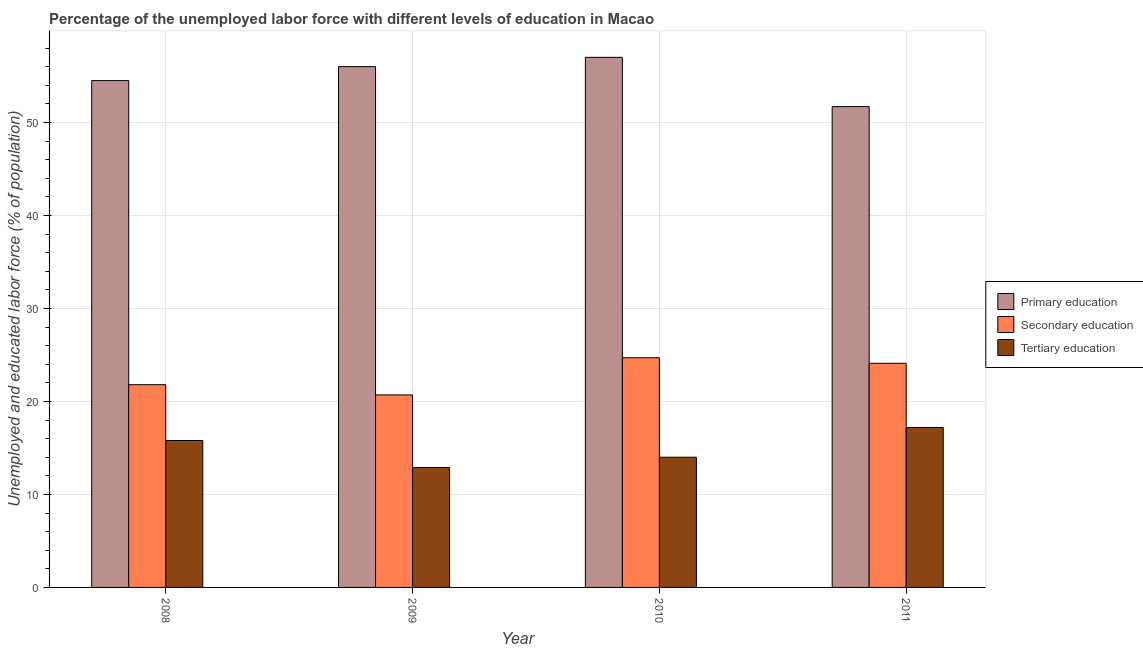How many groups of bars are there?
Make the answer very short. 4. Are the number of bars per tick equal to the number of legend labels?
Keep it short and to the point. Yes. How many bars are there on the 1st tick from the right?
Ensure brevity in your answer.  3. What is the label of the 1st group of bars from the left?
Ensure brevity in your answer.  2008. What is the percentage of labor force who received secondary education in 2008?
Offer a terse response. 21.8. Across all years, what is the minimum percentage of labor force who received secondary education?
Make the answer very short. 20.7. In which year was the percentage of labor force who received secondary education maximum?
Keep it short and to the point. 2010. What is the total percentage of labor force who received tertiary education in the graph?
Give a very brief answer. 59.9. What is the difference between the percentage of labor force who received secondary education in 2008 and that in 2011?
Offer a terse response. -2.3. What is the difference between the percentage of labor force who received primary education in 2011 and the percentage of labor force who received secondary education in 2009?
Your response must be concise. -4.3. What is the average percentage of labor force who received tertiary education per year?
Provide a succinct answer. 14.98. In the year 2010, what is the difference between the percentage of labor force who received secondary education and percentage of labor force who received tertiary education?
Your answer should be very brief. 0. What is the ratio of the percentage of labor force who received tertiary education in 2008 to that in 2011?
Give a very brief answer. 0.92. What is the difference between the highest and the second highest percentage of labor force who received primary education?
Give a very brief answer. 1. What is the difference between the highest and the lowest percentage of labor force who received tertiary education?
Make the answer very short. 4.3. What does the 3rd bar from the left in 2010 represents?
Offer a very short reply. Tertiary education. How many bars are there?
Your answer should be very brief. 12. Are all the bars in the graph horizontal?
Your response must be concise. No. How many years are there in the graph?
Keep it short and to the point. 4. Does the graph contain any zero values?
Your response must be concise. No. How many legend labels are there?
Make the answer very short. 3. How are the legend labels stacked?
Give a very brief answer. Vertical. What is the title of the graph?
Your answer should be compact. Percentage of the unemployed labor force with different levels of education in Macao. Does "Taxes on goods and services" appear as one of the legend labels in the graph?
Offer a very short reply. No. What is the label or title of the X-axis?
Offer a terse response. Year. What is the label or title of the Y-axis?
Your answer should be very brief. Unemployed and educated labor force (% of population). What is the Unemployed and educated labor force (% of population) of Primary education in 2008?
Ensure brevity in your answer.  54.5. What is the Unemployed and educated labor force (% of population) in Secondary education in 2008?
Ensure brevity in your answer.  21.8. What is the Unemployed and educated labor force (% of population) in Tertiary education in 2008?
Your answer should be compact. 15.8. What is the Unemployed and educated labor force (% of population) in Secondary education in 2009?
Your answer should be compact. 20.7. What is the Unemployed and educated labor force (% of population) of Tertiary education in 2009?
Your answer should be compact. 12.9. What is the Unemployed and educated labor force (% of population) of Primary education in 2010?
Your answer should be compact. 57. What is the Unemployed and educated labor force (% of population) in Secondary education in 2010?
Give a very brief answer. 24.7. What is the Unemployed and educated labor force (% of population) of Tertiary education in 2010?
Ensure brevity in your answer.  14. What is the Unemployed and educated labor force (% of population) in Primary education in 2011?
Your response must be concise. 51.7. What is the Unemployed and educated labor force (% of population) in Secondary education in 2011?
Provide a succinct answer. 24.1. What is the Unemployed and educated labor force (% of population) in Tertiary education in 2011?
Give a very brief answer. 17.2. Across all years, what is the maximum Unemployed and educated labor force (% of population) of Secondary education?
Offer a terse response. 24.7. Across all years, what is the maximum Unemployed and educated labor force (% of population) of Tertiary education?
Provide a short and direct response. 17.2. Across all years, what is the minimum Unemployed and educated labor force (% of population) in Primary education?
Provide a succinct answer. 51.7. Across all years, what is the minimum Unemployed and educated labor force (% of population) of Secondary education?
Make the answer very short. 20.7. Across all years, what is the minimum Unemployed and educated labor force (% of population) in Tertiary education?
Provide a short and direct response. 12.9. What is the total Unemployed and educated labor force (% of population) of Primary education in the graph?
Make the answer very short. 219.2. What is the total Unemployed and educated labor force (% of population) in Secondary education in the graph?
Give a very brief answer. 91.3. What is the total Unemployed and educated labor force (% of population) of Tertiary education in the graph?
Your answer should be compact. 59.9. What is the difference between the Unemployed and educated labor force (% of population) of Secondary education in 2008 and that in 2009?
Your answer should be compact. 1.1. What is the difference between the Unemployed and educated labor force (% of population) in Primary education in 2008 and that in 2011?
Provide a succinct answer. 2.8. What is the difference between the Unemployed and educated labor force (% of population) of Tertiary education in 2008 and that in 2011?
Your response must be concise. -1.4. What is the difference between the Unemployed and educated labor force (% of population) of Primary education in 2009 and that in 2010?
Your answer should be very brief. -1. What is the difference between the Unemployed and educated labor force (% of population) in Secondary education in 2009 and that in 2010?
Your answer should be compact. -4. What is the difference between the Unemployed and educated labor force (% of population) in Tertiary education in 2009 and that in 2011?
Keep it short and to the point. -4.3. What is the difference between the Unemployed and educated labor force (% of population) in Primary education in 2010 and that in 2011?
Make the answer very short. 5.3. What is the difference between the Unemployed and educated labor force (% of population) of Primary education in 2008 and the Unemployed and educated labor force (% of population) of Secondary education in 2009?
Make the answer very short. 33.8. What is the difference between the Unemployed and educated labor force (% of population) in Primary education in 2008 and the Unemployed and educated labor force (% of population) in Tertiary education in 2009?
Give a very brief answer. 41.6. What is the difference between the Unemployed and educated labor force (% of population) of Secondary education in 2008 and the Unemployed and educated labor force (% of population) of Tertiary education in 2009?
Offer a very short reply. 8.9. What is the difference between the Unemployed and educated labor force (% of population) in Primary education in 2008 and the Unemployed and educated labor force (% of population) in Secondary education in 2010?
Keep it short and to the point. 29.8. What is the difference between the Unemployed and educated labor force (% of population) in Primary education in 2008 and the Unemployed and educated labor force (% of population) in Tertiary education in 2010?
Your answer should be very brief. 40.5. What is the difference between the Unemployed and educated labor force (% of population) of Primary education in 2008 and the Unemployed and educated labor force (% of population) of Secondary education in 2011?
Keep it short and to the point. 30.4. What is the difference between the Unemployed and educated labor force (% of population) of Primary education in 2008 and the Unemployed and educated labor force (% of population) of Tertiary education in 2011?
Offer a very short reply. 37.3. What is the difference between the Unemployed and educated labor force (% of population) of Secondary education in 2008 and the Unemployed and educated labor force (% of population) of Tertiary education in 2011?
Your response must be concise. 4.6. What is the difference between the Unemployed and educated labor force (% of population) in Primary education in 2009 and the Unemployed and educated labor force (% of population) in Secondary education in 2010?
Provide a short and direct response. 31.3. What is the difference between the Unemployed and educated labor force (% of population) of Primary education in 2009 and the Unemployed and educated labor force (% of population) of Secondary education in 2011?
Keep it short and to the point. 31.9. What is the difference between the Unemployed and educated labor force (% of population) of Primary education in 2009 and the Unemployed and educated labor force (% of population) of Tertiary education in 2011?
Give a very brief answer. 38.8. What is the difference between the Unemployed and educated labor force (% of population) of Secondary education in 2009 and the Unemployed and educated labor force (% of population) of Tertiary education in 2011?
Your answer should be very brief. 3.5. What is the difference between the Unemployed and educated labor force (% of population) of Primary education in 2010 and the Unemployed and educated labor force (% of population) of Secondary education in 2011?
Your answer should be very brief. 32.9. What is the difference between the Unemployed and educated labor force (% of population) of Primary education in 2010 and the Unemployed and educated labor force (% of population) of Tertiary education in 2011?
Offer a very short reply. 39.8. What is the average Unemployed and educated labor force (% of population) in Primary education per year?
Give a very brief answer. 54.8. What is the average Unemployed and educated labor force (% of population) in Secondary education per year?
Offer a very short reply. 22.82. What is the average Unemployed and educated labor force (% of population) of Tertiary education per year?
Ensure brevity in your answer.  14.97. In the year 2008, what is the difference between the Unemployed and educated labor force (% of population) of Primary education and Unemployed and educated labor force (% of population) of Secondary education?
Your answer should be very brief. 32.7. In the year 2008, what is the difference between the Unemployed and educated labor force (% of population) in Primary education and Unemployed and educated labor force (% of population) in Tertiary education?
Ensure brevity in your answer.  38.7. In the year 2008, what is the difference between the Unemployed and educated labor force (% of population) in Secondary education and Unemployed and educated labor force (% of population) in Tertiary education?
Offer a terse response. 6. In the year 2009, what is the difference between the Unemployed and educated labor force (% of population) of Primary education and Unemployed and educated labor force (% of population) of Secondary education?
Keep it short and to the point. 35.3. In the year 2009, what is the difference between the Unemployed and educated labor force (% of population) of Primary education and Unemployed and educated labor force (% of population) of Tertiary education?
Make the answer very short. 43.1. In the year 2010, what is the difference between the Unemployed and educated labor force (% of population) of Primary education and Unemployed and educated labor force (% of population) of Secondary education?
Keep it short and to the point. 32.3. In the year 2010, what is the difference between the Unemployed and educated labor force (% of population) in Secondary education and Unemployed and educated labor force (% of population) in Tertiary education?
Offer a terse response. 10.7. In the year 2011, what is the difference between the Unemployed and educated labor force (% of population) in Primary education and Unemployed and educated labor force (% of population) in Secondary education?
Offer a very short reply. 27.6. In the year 2011, what is the difference between the Unemployed and educated labor force (% of population) of Primary education and Unemployed and educated labor force (% of population) of Tertiary education?
Provide a short and direct response. 34.5. In the year 2011, what is the difference between the Unemployed and educated labor force (% of population) in Secondary education and Unemployed and educated labor force (% of population) in Tertiary education?
Provide a succinct answer. 6.9. What is the ratio of the Unemployed and educated labor force (% of population) of Primary education in 2008 to that in 2009?
Your response must be concise. 0.97. What is the ratio of the Unemployed and educated labor force (% of population) in Secondary education in 2008 to that in 2009?
Keep it short and to the point. 1.05. What is the ratio of the Unemployed and educated labor force (% of population) in Tertiary education in 2008 to that in 2009?
Offer a very short reply. 1.22. What is the ratio of the Unemployed and educated labor force (% of population) of Primary education in 2008 to that in 2010?
Your response must be concise. 0.96. What is the ratio of the Unemployed and educated labor force (% of population) in Secondary education in 2008 to that in 2010?
Your answer should be compact. 0.88. What is the ratio of the Unemployed and educated labor force (% of population) in Tertiary education in 2008 to that in 2010?
Make the answer very short. 1.13. What is the ratio of the Unemployed and educated labor force (% of population) in Primary education in 2008 to that in 2011?
Provide a succinct answer. 1.05. What is the ratio of the Unemployed and educated labor force (% of population) in Secondary education in 2008 to that in 2011?
Provide a succinct answer. 0.9. What is the ratio of the Unemployed and educated labor force (% of population) of Tertiary education in 2008 to that in 2011?
Make the answer very short. 0.92. What is the ratio of the Unemployed and educated labor force (% of population) of Primary education in 2009 to that in 2010?
Your answer should be very brief. 0.98. What is the ratio of the Unemployed and educated labor force (% of population) in Secondary education in 2009 to that in 2010?
Make the answer very short. 0.84. What is the ratio of the Unemployed and educated labor force (% of population) in Tertiary education in 2009 to that in 2010?
Provide a short and direct response. 0.92. What is the ratio of the Unemployed and educated labor force (% of population) of Primary education in 2009 to that in 2011?
Offer a very short reply. 1.08. What is the ratio of the Unemployed and educated labor force (% of population) in Secondary education in 2009 to that in 2011?
Offer a terse response. 0.86. What is the ratio of the Unemployed and educated labor force (% of population) in Primary education in 2010 to that in 2011?
Provide a succinct answer. 1.1. What is the ratio of the Unemployed and educated labor force (% of population) in Secondary education in 2010 to that in 2011?
Keep it short and to the point. 1.02. What is the ratio of the Unemployed and educated labor force (% of population) of Tertiary education in 2010 to that in 2011?
Your answer should be compact. 0.81. What is the difference between the highest and the second highest Unemployed and educated labor force (% of population) of Secondary education?
Offer a terse response. 0.6. What is the difference between the highest and the lowest Unemployed and educated labor force (% of population) in Secondary education?
Give a very brief answer. 4. 